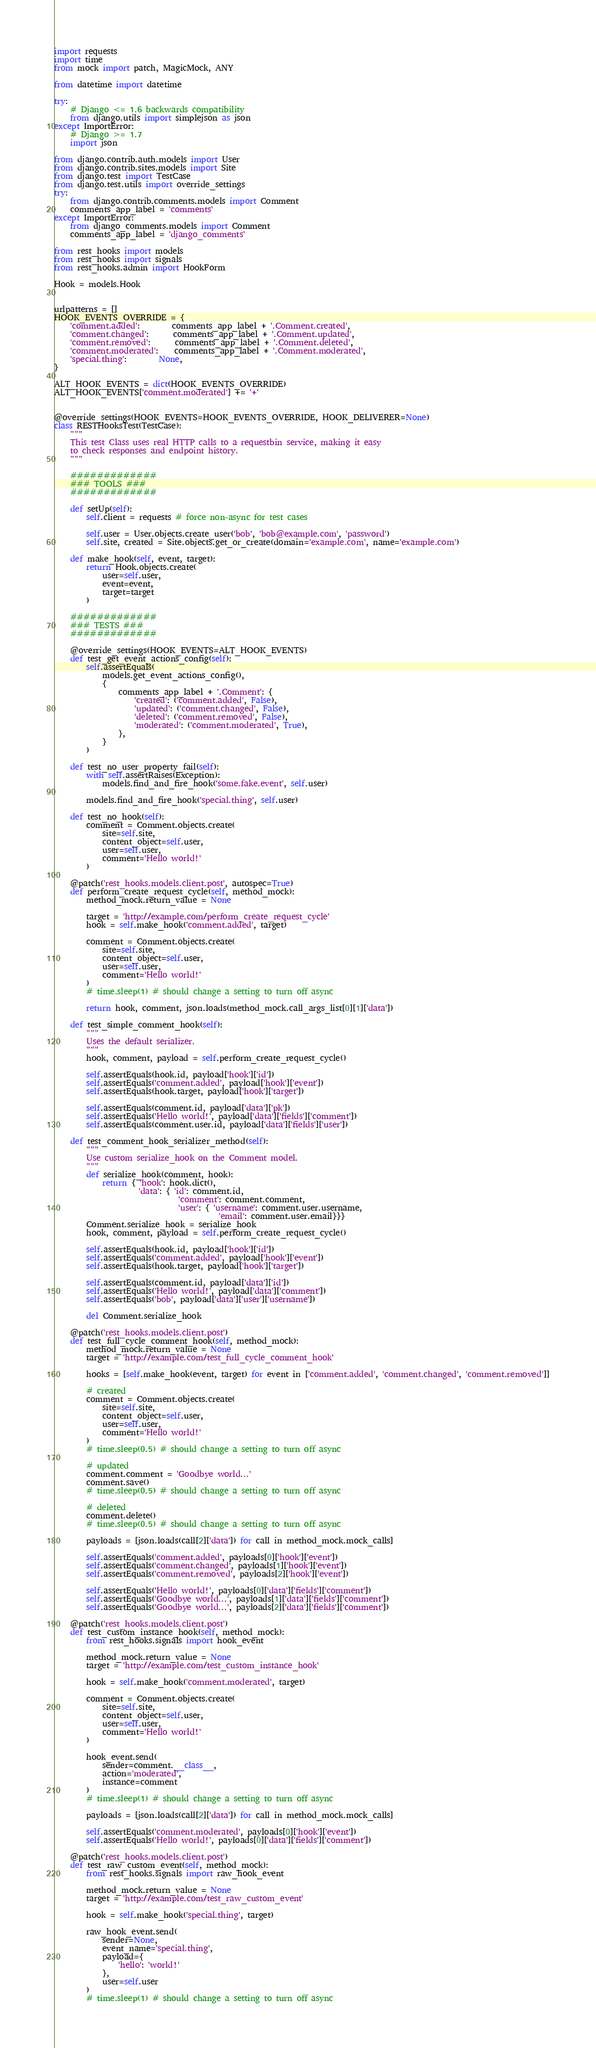<code> <loc_0><loc_0><loc_500><loc_500><_Python_>import requests
import time
from mock import patch, MagicMock, ANY

from datetime import datetime

try:
    # Django <= 1.6 backwards compatibility
    from django.utils import simplejson as json
except ImportError:
    # Django >= 1.7
    import json

from django.contrib.auth.models import User
from django.contrib.sites.models import Site
from django.test import TestCase
from django.test.utils import override_settings
try:
    from django.contrib.comments.models import Comment
    comments_app_label = 'comments'
except ImportError:
    from django_comments.models import Comment
    comments_app_label = 'django_comments'

from rest_hooks import models
from rest_hooks import signals
from rest_hooks.admin import HookForm

Hook = models.Hook


urlpatterns = []
HOOK_EVENTS_OVERRIDE = {
    'comment.added':        comments_app_label + '.Comment.created',
    'comment.changed':      comments_app_label + '.Comment.updated',
    'comment.removed':      comments_app_label + '.Comment.deleted',
    'comment.moderated':    comments_app_label + '.Comment.moderated',
    'special.thing':        None,
}

ALT_HOOK_EVENTS = dict(HOOK_EVENTS_OVERRIDE)
ALT_HOOK_EVENTS['comment.moderated'] += '+'


@override_settings(HOOK_EVENTS=HOOK_EVENTS_OVERRIDE, HOOK_DELIVERER=None)
class RESTHooksTest(TestCase):
    """
    This test Class uses real HTTP calls to a requestbin service, making it easy
    to check responses and endpoint history.
    """

    #############
    ### TOOLS ###
    #############

    def setUp(self):
        self.client = requests # force non-async for test cases

        self.user = User.objects.create_user('bob', 'bob@example.com', 'password')
        self.site, created = Site.objects.get_or_create(domain='example.com', name='example.com')

    def make_hook(self, event, target):
        return Hook.objects.create(
            user=self.user,
            event=event,
            target=target
        )

    #############
    ### TESTS ###
    #############

    @override_settings(HOOK_EVENTS=ALT_HOOK_EVENTS)
    def test_get_event_actions_config(self):
        self.assertEquals(
            models.get_event_actions_config(),
            {
                comments_app_label + '.Comment': {
                    'created': ('comment.added', False),
                    'updated': ('comment.changed', False),
                    'deleted': ('comment.removed', False),
                    'moderated': ('comment.moderated', True),
                },
            }
        )

    def test_no_user_property_fail(self):
        with self.assertRaises(Exception):
            models.find_and_fire_hook('some.fake.event', self.user)

        models.find_and_fire_hook('special.thing', self.user)

    def test_no_hook(self):
        comment = Comment.objects.create(
            site=self.site,
            content_object=self.user,
            user=self.user,
            comment='Hello world!'
        )

    @patch('rest_hooks.models.client.post', autospec=True)
    def perform_create_request_cycle(self, method_mock):
        method_mock.return_value = None

        target = 'http://example.com/perform_create_request_cycle'
        hook = self.make_hook('comment.added', target)

        comment = Comment.objects.create(
            site=self.site,
            content_object=self.user,
            user=self.user,
            comment='Hello world!'
        )
        # time.sleep(1) # should change a setting to turn off async

        return hook, comment, json.loads(method_mock.call_args_list[0][1]['data'])

    def test_simple_comment_hook(self):
        """
        Uses the default serializer.
        """
        hook, comment, payload = self.perform_create_request_cycle()

        self.assertEquals(hook.id, payload['hook']['id'])
        self.assertEquals('comment.added', payload['hook']['event'])
        self.assertEquals(hook.target, payload['hook']['target'])

        self.assertEquals(comment.id, payload['data']['pk'])
        self.assertEquals('Hello world!', payload['data']['fields']['comment'])
        self.assertEquals(comment.user.id, payload['data']['fields']['user'])

    def test_comment_hook_serializer_method(self):
        """
        Use custom serialize_hook on the Comment model.
        """
        def serialize_hook(comment, hook):
            return { 'hook': hook.dict(),
                     'data': { 'id': comment.id,
                               'comment': comment.comment,
                               'user': { 'username': comment.user.username,
                                         'email': comment.user.email}}}
        Comment.serialize_hook = serialize_hook
        hook, comment, payload = self.perform_create_request_cycle()

        self.assertEquals(hook.id, payload['hook']['id'])
        self.assertEquals('comment.added', payload['hook']['event'])
        self.assertEquals(hook.target, payload['hook']['target'])

        self.assertEquals(comment.id, payload['data']['id'])
        self.assertEquals('Hello world!', payload['data']['comment'])
        self.assertEquals('bob', payload['data']['user']['username'])

        del Comment.serialize_hook

    @patch('rest_hooks.models.client.post')
    def test_full_cycle_comment_hook(self, method_mock):
        method_mock.return_value = None
        target = 'http://example.com/test_full_cycle_comment_hook'

        hooks = [self.make_hook(event, target) for event in ['comment.added', 'comment.changed', 'comment.removed']]

        # created
        comment = Comment.objects.create(
            site=self.site,
            content_object=self.user,
            user=self.user,
            comment='Hello world!'
        )
        # time.sleep(0.5) # should change a setting to turn off async

        # updated
        comment.comment = 'Goodbye world...'
        comment.save()
        # time.sleep(0.5) # should change a setting to turn off async

        # deleted
        comment.delete()
        # time.sleep(0.5) # should change a setting to turn off async

        payloads = [json.loads(call[2]['data']) for call in method_mock.mock_calls]

        self.assertEquals('comment.added', payloads[0]['hook']['event'])
        self.assertEquals('comment.changed', payloads[1]['hook']['event'])
        self.assertEquals('comment.removed', payloads[2]['hook']['event'])

        self.assertEquals('Hello world!', payloads[0]['data']['fields']['comment'])
        self.assertEquals('Goodbye world...', payloads[1]['data']['fields']['comment'])
        self.assertEquals('Goodbye world...', payloads[2]['data']['fields']['comment'])

    @patch('rest_hooks.models.client.post')
    def test_custom_instance_hook(self, method_mock):
        from rest_hooks.signals import hook_event

        method_mock.return_value = None
        target = 'http://example.com/test_custom_instance_hook'

        hook = self.make_hook('comment.moderated', target)

        comment = Comment.objects.create(
            site=self.site,
            content_object=self.user,
            user=self.user,
            comment='Hello world!'
        )

        hook_event.send(
            sender=comment.__class__,
            action='moderated',
            instance=comment
        )
        # time.sleep(1) # should change a setting to turn off async

        payloads = [json.loads(call[2]['data']) for call in method_mock.mock_calls]

        self.assertEquals('comment.moderated', payloads[0]['hook']['event'])
        self.assertEquals('Hello world!', payloads[0]['data']['fields']['comment'])

    @patch('rest_hooks.models.client.post')
    def test_raw_custom_event(self, method_mock):
        from rest_hooks.signals import raw_hook_event

        method_mock.return_value = None
        target = 'http://example.com/test_raw_custom_event'

        hook = self.make_hook('special.thing', target)

        raw_hook_event.send(
            sender=None,
            event_name='special.thing',
            payload={
                'hello': 'world!'
            },
            user=self.user
        )
        # time.sleep(1) # should change a setting to turn off async
</code> 